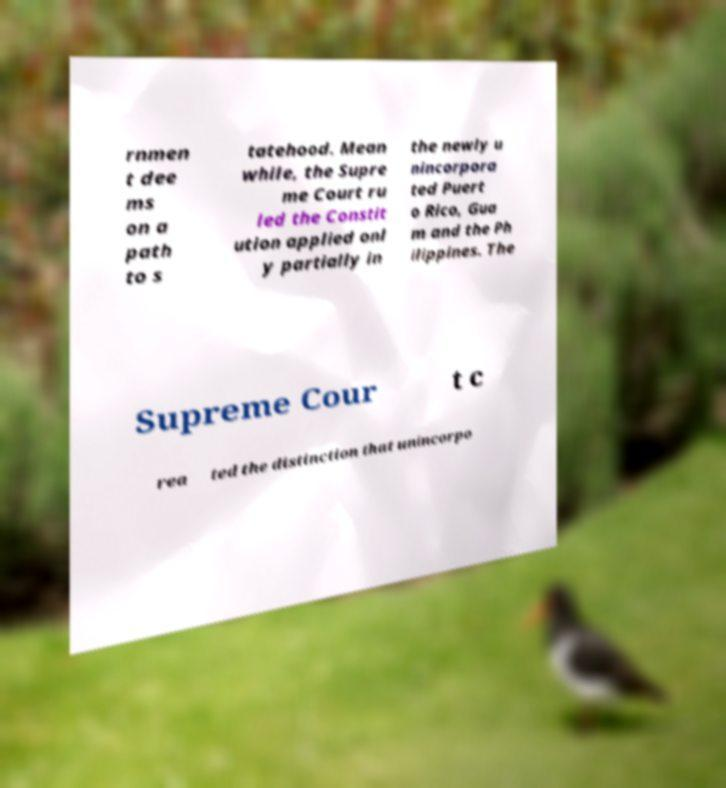For documentation purposes, I need the text within this image transcribed. Could you provide that? rnmen t dee ms on a path to s tatehood. Mean while, the Supre me Court ru led the Constit ution applied onl y partially in the newly u nincorpora ted Puert o Rico, Gua m and the Ph ilippines. The Supreme Cour t c rea ted the distinction that unincorpo 